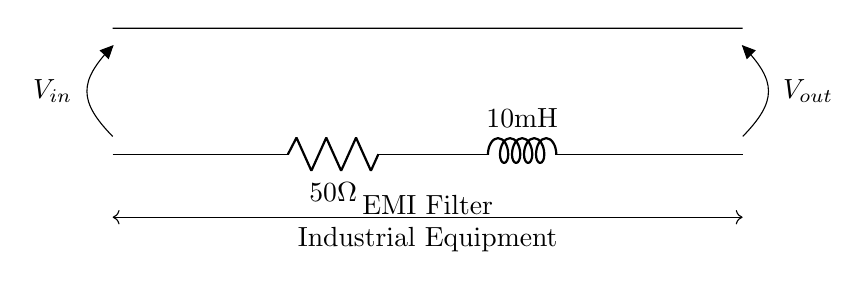What is the value of the resistor? The resistor value is indicated in the circuit diagram as 50 ohms.
Answer: 50 ohms What is the value of the inductor? The inductor value shown in the circuit is 10 millihenries.
Answer: 10 millihenries Where is the input voltage applied? The input voltage is connected to the left side of the circuit, marked as V_in.
Answer: Left side What is the purpose of this circuit? This circuit acts as an electromagnetic interference filter for industrial equipment.
Answer: EMI Filter What happens to high-frequency signals in this RL circuit? High-frequency signals are attenuated more than low-frequency signals due to the properties of the resistor and inductor.
Answer: Attenuated How does the inductor affect the output voltage? The inductor allows low-frequency signals to pass while resisting rapid changes in current, hence shaping the output voltage.
Answer: Shapes output voltage What component limits the current in the circuit? The resistor limits the current flowing in the circuit according to Ohm's law.
Answer: Resistor 